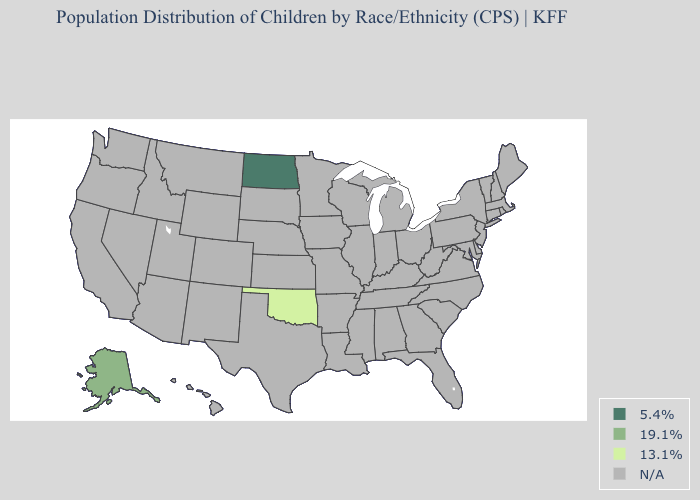Name the states that have a value in the range 5.4%?
Answer briefly. North Dakota. Name the states that have a value in the range 19.1%?
Give a very brief answer. Alaska. What is the value of Colorado?
Give a very brief answer. N/A. What is the value of North Carolina?
Keep it brief. N/A. Name the states that have a value in the range N/A?
Be succinct. Alabama, Arizona, Arkansas, California, Colorado, Connecticut, Delaware, Florida, Georgia, Hawaii, Idaho, Illinois, Indiana, Iowa, Kansas, Kentucky, Louisiana, Maine, Maryland, Massachusetts, Michigan, Minnesota, Mississippi, Missouri, Montana, Nebraska, Nevada, New Hampshire, New Jersey, New Mexico, New York, North Carolina, Ohio, Oregon, Pennsylvania, Rhode Island, South Carolina, South Dakota, Tennessee, Texas, Utah, Vermont, Virginia, Washington, West Virginia, Wisconsin, Wyoming. Name the states that have a value in the range 5.4%?
Be succinct. North Dakota. Does the first symbol in the legend represent the smallest category?
Short answer required. No. What is the lowest value in the USA?
Give a very brief answer. 13.1%. Which states hav the highest value in the West?
Short answer required. Alaska. 